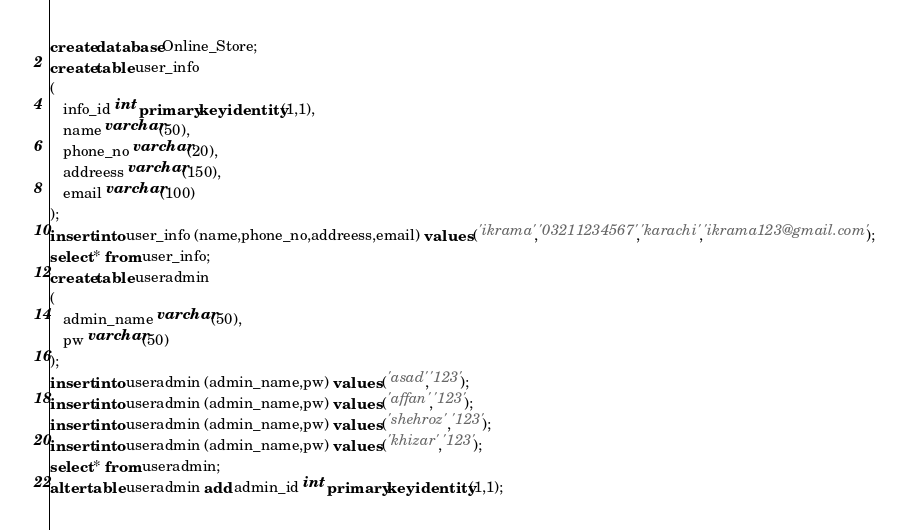Convert code to text. <code><loc_0><loc_0><loc_500><loc_500><_SQL_>create database Online_Store;
create table user_info
(
   info_id int primary key identity(1,1),
   name varchar(50),
   phone_no varchar(20),
   addreess varchar(150),
   email varchar(100)
);
insert into user_info (name,phone_no,addreess,email) values ('ikrama','03211234567','karachi','ikrama123@gmail.com');
select * from user_info;
create table useradmin
(
   admin_name varchar(50),
   pw varchar(50)
);
insert into useradmin (admin_name,pw) values ('asad','123');
insert into useradmin (admin_name,pw) values ('affan','123');
insert into useradmin (admin_name,pw) values ('shehroz','123');
insert into useradmin (admin_name,pw) values ('khizar','123');
select * from useradmin;
alter table useradmin add admin_id int primary key identity(1,1);</code> 